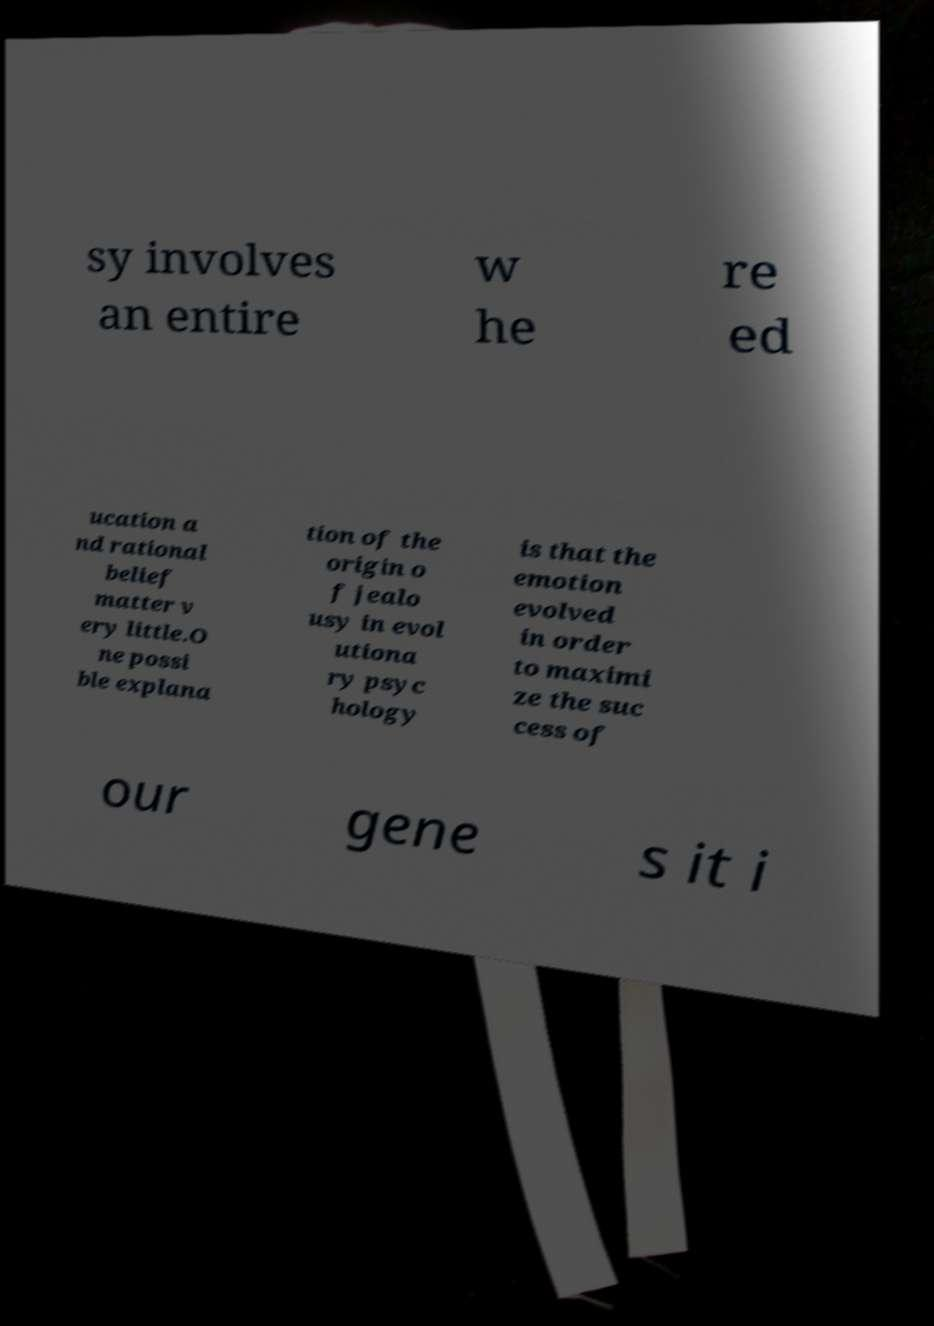Please read and relay the text visible in this image. What does it say? sy involves an entire w he re ed ucation a nd rational belief matter v ery little.O ne possi ble explana tion of the origin o f jealo usy in evol utiona ry psyc hology is that the emotion evolved in order to maximi ze the suc cess of our gene s it i 